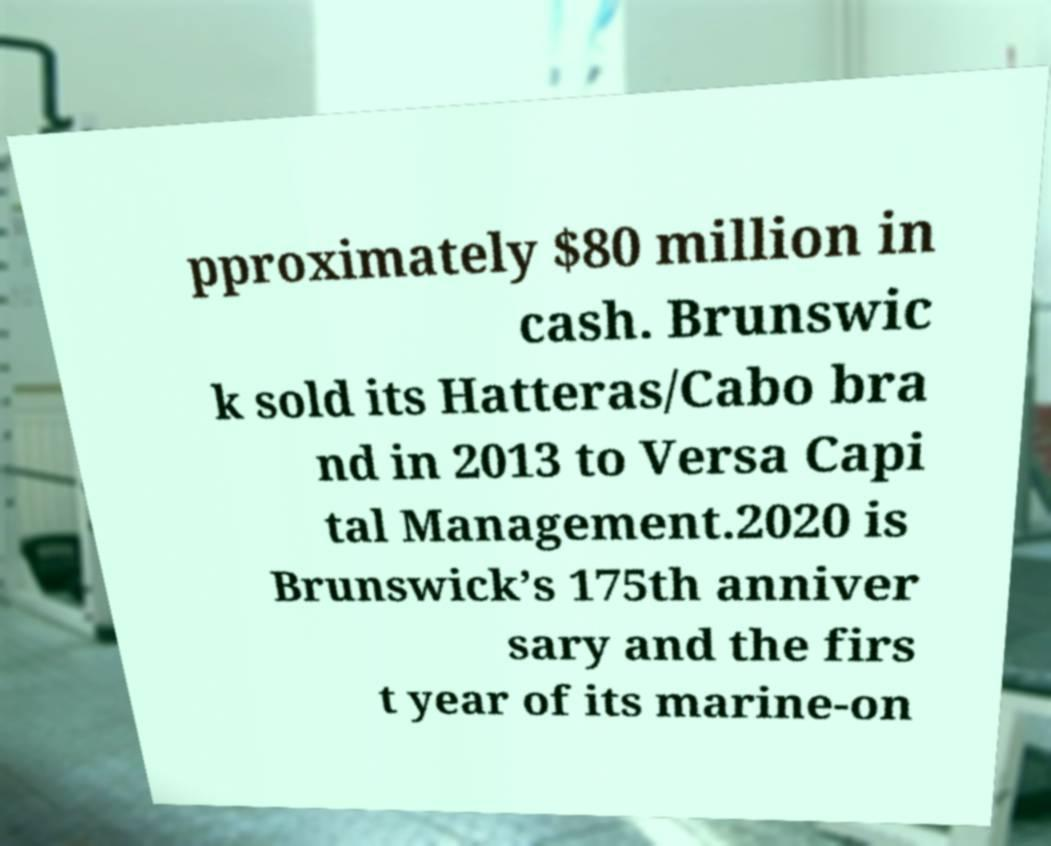There's text embedded in this image that I need extracted. Can you transcribe it verbatim? pproximately $80 million in cash. Brunswic k sold its Hatteras/Cabo bra nd in 2013 to Versa Capi tal Management.2020 is Brunswick’s 175th anniver sary and the firs t year of its marine-on 